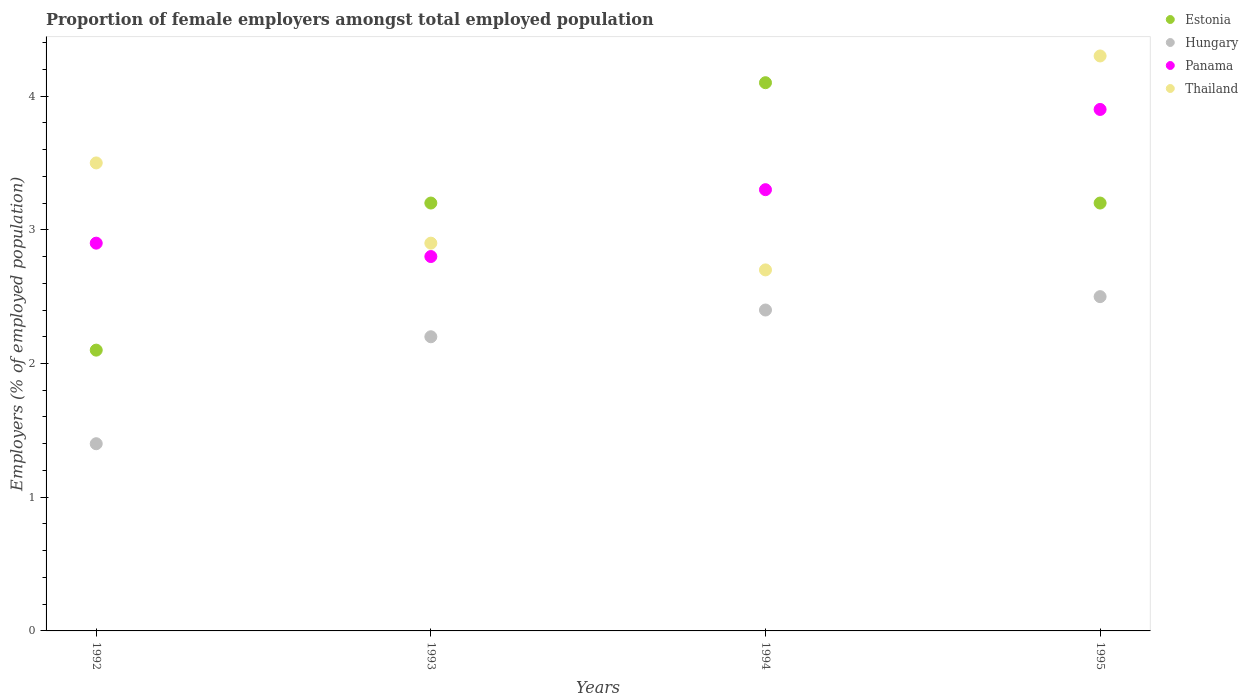What is the proportion of female employers in Estonia in 1994?
Provide a short and direct response. 4.1. Across all years, what is the minimum proportion of female employers in Hungary?
Offer a very short reply. 1.4. What is the total proportion of female employers in Panama in the graph?
Your answer should be very brief. 12.9. What is the difference between the proportion of female employers in Hungary in 1992 and that in 1994?
Make the answer very short. -1. What is the difference between the proportion of female employers in Estonia in 1994 and the proportion of female employers in Thailand in 1995?
Your answer should be very brief. -0.2. What is the average proportion of female employers in Estonia per year?
Offer a terse response. 3.15. In the year 1994, what is the difference between the proportion of female employers in Thailand and proportion of female employers in Hungary?
Provide a succinct answer. 0.3. In how many years, is the proportion of female employers in Hungary greater than 0.6000000000000001 %?
Offer a terse response. 4. What is the ratio of the proportion of female employers in Thailand in 1992 to that in 1994?
Ensure brevity in your answer.  1.3. Is the proportion of female employers in Panama in 1992 less than that in 1993?
Provide a short and direct response. No. Is the difference between the proportion of female employers in Thailand in 1992 and 1995 greater than the difference between the proportion of female employers in Hungary in 1992 and 1995?
Offer a very short reply. Yes. What is the difference between the highest and the second highest proportion of female employers in Estonia?
Keep it short and to the point. 0.9. What is the difference between the highest and the lowest proportion of female employers in Hungary?
Provide a short and direct response. 1.1. Is it the case that in every year, the sum of the proportion of female employers in Thailand and proportion of female employers in Hungary  is greater than the proportion of female employers in Panama?
Ensure brevity in your answer.  Yes. Does the proportion of female employers in Thailand monotonically increase over the years?
Give a very brief answer. No. Is the proportion of female employers in Panama strictly greater than the proportion of female employers in Thailand over the years?
Keep it short and to the point. No. How many dotlines are there?
Offer a terse response. 4. How many years are there in the graph?
Offer a terse response. 4. What is the difference between two consecutive major ticks on the Y-axis?
Offer a terse response. 1. Are the values on the major ticks of Y-axis written in scientific E-notation?
Your response must be concise. No. Does the graph contain any zero values?
Your answer should be compact. No. Does the graph contain grids?
Offer a terse response. No. How are the legend labels stacked?
Your answer should be compact. Vertical. What is the title of the graph?
Your response must be concise. Proportion of female employers amongst total employed population. Does "Philippines" appear as one of the legend labels in the graph?
Keep it short and to the point. No. What is the label or title of the X-axis?
Ensure brevity in your answer.  Years. What is the label or title of the Y-axis?
Offer a very short reply. Employers (% of employed population). What is the Employers (% of employed population) in Estonia in 1992?
Offer a terse response. 2.1. What is the Employers (% of employed population) of Hungary in 1992?
Offer a very short reply. 1.4. What is the Employers (% of employed population) of Panama in 1992?
Your response must be concise. 2.9. What is the Employers (% of employed population) of Thailand in 1992?
Your answer should be very brief. 3.5. What is the Employers (% of employed population) in Estonia in 1993?
Offer a terse response. 3.2. What is the Employers (% of employed population) of Hungary in 1993?
Provide a succinct answer. 2.2. What is the Employers (% of employed population) of Panama in 1993?
Keep it short and to the point. 2.8. What is the Employers (% of employed population) of Thailand in 1993?
Ensure brevity in your answer.  2.9. What is the Employers (% of employed population) of Estonia in 1994?
Make the answer very short. 4.1. What is the Employers (% of employed population) of Hungary in 1994?
Provide a succinct answer. 2.4. What is the Employers (% of employed population) in Panama in 1994?
Your response must be concise. 3.3. What is the Employers (% of employed population) of Thailand in 1994?
Ensure brevity in your answer.  2.7. What is the Employers (% of employed population) of Estonia in 1995?
Offer a terse response. 3.2. What is the Employers (% of employed population) in Hungary in 1995?
Provide a succinct answer. 2.5. What is the Employers (% of employed population) of Panama in 1995?
Ensure brevity in your answer.  3.9. What is the Employers (% of employed population) in Thailand in 1995?
Your response must be concise. 4.3. Across all years, what is the maximum Employers (% of employed population) in Estonia?
Give a very brief answer. 4.1. Across all years, what is the maximum Employers (% of employed population) in Panama?
Provide a short and direct response. 3.9. Across all years, what is the maximum Employers (% of employed population) in Thailand?
Keep it short and to the point. 4.3. Across all years, what is the minimum Employers (% of employed population) of Estonia?
Make the answer very short. 2.1. Across all years, what is the minimum Employers (% of employed population) of Hungary?
Ensure brevity in your answer.  1.4. Across all years, what is the minimum Employers (% of employed population) of Panama?
Provide a succinct answer. 2.8. Across all years, what is the minimum Employers (% of employed population) of Thailand?
Offer a terse response. 2.7. What is the total Employers (% of employed population) in Estonia in the graph?
Your answer should be very brief. 12.6. What is the total Employers (% of employed population) in Hungary in the graph?
Your answer should be compact. 8.5. What is the difference between the Employers (% of employed population) of Estonia in 1992 and that in 1993?
Your answer should be very brief. -1.1. What is the difference between the Employers (% of employed population) of Hungary in 1992 and that in 1993?
Keep it short and to the point. -0.8. What is the difference between the Employers (% of employed population) in Estonia in 1992 and that in 1994?
Give a very brief answer. -2. What is the difference between the Employers (% of employed population) of Hungary in 1992 and that in 1994?
Ensure brevity in your answer.  -1. What is the difference between the Employers (% of employed population) in Thailand in 1992 and that in 1994?
Make the answer very short. 0.8. What is the difference between the Employers (% of employed population) of Estonia in 1992 and that in 1995?
Give a very brief answer. -1.1. What is the difference between the Employers (% of employed population) in Hungary in 1992 and that in 1995?
Your answer should be compact. -1.1. What is the difference between the Employers (% of employed population) of Panama in 1992 and that in 1995?
Ensure brevity in your answer.  -1. What is the difference between the Employers (% of employed population) of Hungary in 1993 and that in 1994?
Give a very brief answer. -0.2. What is the difference between the Employers (% of employed population) of Estonia in 1993 and that in 1995?
Provide a succinct answer. 0. What is the difference between the Employers (% of employed population) of Hungary in 1993 and that in 1995?
Your answer should be very brief. -0.3. What is the difference between the Employers (% of employed population) in Thailand in 1993 and that in 1995?
Offer a very short reply. -1.4. What is the difference between the Employers (% of employed population) of Estonia in 1994 and that in 1995?
Your answer should be very brief. 0.9. What is the difference between the Employers (% of employed population) of Hungary in 1994 and that in 1995?
Ensure brevity in your answer.  -0.1. What is the difference between the Employers (% of employed population) of Estonia in 1992 and the Employers (% of employed population) of Hungary in 1993?
Provide a short and direct response. -0.1. What is the difference between the Employers (% of employed population) in Estonia in 1992 and the Employers (% of employed population) in Thailand in 1993?
Your answer should be very brief. -0.8. What is the difference between the Employers (% of employed population) in Hungary in 1992 and the Employers (% of employed population) in Panama in 1993?
Your answer should be very brief. -1.4. What is the difference between the Employers (% of employed population) in Estonia in 1992 and the Employers (% of employed population) in Hungary in 1994?
Your answer should be compact. -0.3. What is the difference between the Employers (% of employed population) in Estonia in 1992 and the Employers (% of employed population) in Thailand in 1994?
Your response must be concise. -0.6. What is the difference between the Employers (% of employed population) in Hungary in 1992 and the Employers (% of employed population) in Panama in 1994?
Provide a succinct answer. -1.9. What is the difference between the Employers (% of employed population) of Panama in 1992 and the Employers (% of employed population) of Thailand in 1994?
Keep it short and to the point. 0.2. What is the difference between the Employers (% of employed population) of Estonia in 1992 and the Employers (% of employed population) of Hungary in 1995?
Ensure brevity in your answer.  -0.4. What is the difference between the Employers (% of employed population) of Hungary in 1992 and the Employers (% of employed population) of Thailand in 1995?
Your response must be concise. -2.9. What is the difference between the Employers (% of employed population) in Estonia in 1993 and the Employers (% of employed population) in Hungary in 1994?
Make the answer very short. 0.8. What is the difference between the Employers (% of employed population) in Estonia in 1993 and the Employers (% of employed population) in Panama in 1994?
Your answer should be very brief. -0.1. What is the difference between the Employers (% of employed population) of Hungary in 1993 and the Employers (% of employed population) of Thailand in 1994?
Offer a terse response. -0.5. What is the difference between the Employers (% of employed population) of Estonia in 1993 and the Employers (% of employed population) of Panama in 1995?
Give a very brief answer. -0.7. What is the difference between the Employers (% of employed population) in Estonia in 1993 and the Employers (% of employed population) in Thailand in 1995?
Provide a short and direct response. -1.1. What is the difference between the Employers (% of employed population) in Panama in 1993 and the Employers (% of employed population) in Thailand in 1995?
Give a very brief answer. -1.5. What is the difference between the Employers (% of employed population) of Estonia in 1994 and the Employers (% of employed population) of Hungary in 1995?
Provide a succinct answer. 1.6. What is the difference between the Employers (% of employed population) in Estonia in 1994 and the Employers (% of employed population) in Thailand in 1995?
Ensure brevity in your answer.  -0.2. What is the difference between the Employers (% of employed population) of Hungary in 1994 and the Employers (% of employed population) of Thailand in 1995?
Provide a short and direct response. -1.9. What is the difference between the Employers (% of employed population) of Panama in 1994 and the Employers (% of employed population) of Thailand in 1995?
Provide a short and direct response. -1. What is the average Employers (% of employed population) in Estonia per year?
Give a very brief answer. 3.15. What is the average Employers (% of employed population) in Hungary per year?
Offer a very short reply. 2.12. What is the average Employers (% of employed population) in Panama per year?
Your answer should be compact. 3.23. What is the average Employers (% of employed population) of Thailand per year?
Offer a terse response. 3.35. In the year 1992, what is the difference between the Employers (% of employed population) of Hungary and Employers (% of employed population) of Thailand?
Provide a succinct answer. -2.1. In the year 1993, what is the difference between the Employers (% of employed population) in Estonia and Employers (% of employed population) in Thailand?
Make the answer very short. 0.3. In the year 1993, what is the difference between the Employers (% of employed population) of Hungary and Employers (% of employed population) of Panama?
Give a very brief answer. -0.6. In the year 1993, what is the difference between the Employers (% of employed population) in Hungary and Employers (% of employed population) in Thailand?
Keep it short and to the point. -0.7. In the year 1994, what is the difference between the Employers (% of employed population) of Estonia and Employers (% of employed population) of Panama?
Offer a terse response. 0.8. In the year 1994, what is the difference between the Employers (% of employed population) in Hungary and Employers (% of employed population) in Thailand?
Ensure brevity in your answer.  -0.3. In the year 1995, what is the difference between the Employers (% of employed population) of Estonia and Employers (% of employed population) of Panama?
Offer a terse response. -0.7. In the year 1995, what is the difference between the Employers (% of employed population) of Estonia and Employers (% of employed population) of Thailand?
Your answer should be compact. -1.1. In the year 1995, what is the difference between the Employers (% of employed population) in Hungary and Employers (% of employed population) in Panama?
Keep it short and to the point. -1.4. In the year 1995, what is the difference between the Employers (% of employed population) in Hungary and Employers (% of employed population) in Thailand?
Provide a short and direct response. -1.8. In the year 1995, what is the difference between the Employers (% of employed population) of Panama and Employers (% of employed population) of Thailand?
Provide a short and direct response. -0.4. What is the ratio of the Employers (% of employed population) in Estonia in 1992 to that in 1993?
Your response must be concise. 0.66. What is the ratio of the Employers (% of employed population) in Hungary in 1992 to that in 1993?
Offer a very short reply. 0.64. What is the ratio of the Employers (% of employed population) in Panama in 1992 to that in 1993?
Provide a succinct answer. 1.04. What is the ratio of the Employers (% of employed population) of Thailand in 1992 to that in 1993?
Give a very brief answer. 1.21. What is the ratio of the Employers (% of employed population) of Estonia in 1992 to that in 1994?
Provide a short and direct response. 0.51. What is the ratio of the Employers (% of employed population) of Hungary in 1992 to that in 1994?
Provide a succinct answer. 0.58. What is the ratio of the Employers (% of employed population) of Panama in 1992 to that in 1994?
Make the answer very short. 0.88. What is the ratio of the Employers (% of employed population) in Thailand in 1992 to that in 1994?
Offer a very short reply. 1.3. What is the ratio of the Employers (% of employed population) in Estonia in 1992 to that in 1995?
Give a very brief answer. 0.66. What is the ratio of the Employers (% of employed population) of Hungary in 1992 to that in 1995?
Make the answer very short. 0.56. What is the ratio of the Employers (% of employed population) in Panama in 1992 to that in 1995?
Keep it short and to the point. 0.74. What is the ratio of the Employers (% of employed population) in Thailand in 1992 to that in 1995?
Make the answer very short. 0.81. What is the ratio of the Employers (% of employed population) of Estonia in 1993 to that in 1994?
Ensure brevity in your answer.  0.78. What is the ratio of the Employers (% of employed population) of Hungary in 1993 to that in 1994?
Give a very brief answer. 0.92. What is the ratio of the Employers (% of employed population) of Panama in 1993 to that in 1994?
Your answer should be compact. 0.85. What is the ratio of the Employers (% of employed population) in Thailand in 1993 to that in 1994?
Your answer should be compact. 1.07. What is the ratio of the Employers (% of employed population) in Hungary in 1993 to that in 1995?
Provide a short and direct response. 0.88. What is the ratio of the Employers (% of employed population) of Panama in 1993 to that in 1995?
Your answer should be very brief. 0.72. What is the ratio of the Employers (% of employed population) of Thailand in 1993 to that in 1995?
Keep it short and to the point. 0.67. What is the ratio of the Employers (% of employed population) of Estonia in 1994 to that in 1995?
Your answer should be compact. 1.28. What is the ratio of the Employers (% of employed population) in Panama in 1994 to that in 1995?
Ensure brevity in your answer.  0.85. What is the ratio of the Employers (% of employed population) in Thailand in 1994 to that in 1995?
Make the answer very short. 0.63. What is the difference between the highest and the second highest Employers (% of employed population) in Estonia?
Provide a succinct answer. 0.9. What is the difference between the highest and the second highest Employers (% of employed population) in Hungary?
Offer a very short reply. 0.1. What is the difference between the highest and the second highest Employers (% of employed population) in Thailand?
Provide a short and direct response. 0.8. What is the difference between the highest and the lowest Employers (% of employed population) of Estonia?
Make the answer very short. 2. What is the difference between the highest and the lowest Employers (% of employed population) of Hungary?
Make the answer very short. 1.1. What is the difference between the highest and the lowest Employers (% of employed population) in Thailand?
Your answer should be compact. 1.6. 